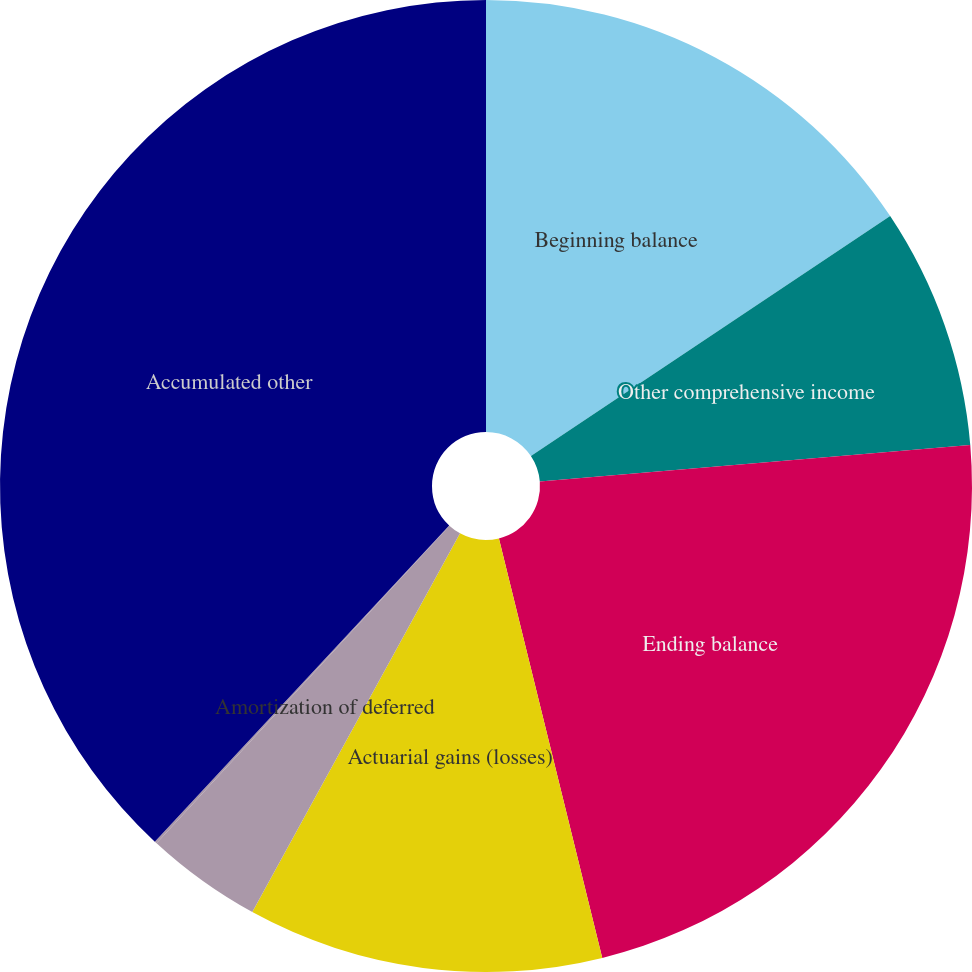Convert chart. <chart><loc_0><loc_0><loc_500><loc_500><pie_chart><fcel>Beginning balance<fcel>Other comprehensive income<fcel>Ending balance<fcel>Actuarial gains (losses)<fcel>Amortization of deferred<fcel>Gains (Losses) deferred during<fcel>Accumulated other<nl><fcel>15.63%<fcel>8.03%<fcel>22.5%<fcel>11.83%<fcel>3.87%<fcel>0.08%<fcel>38.07%<nl></chart> 